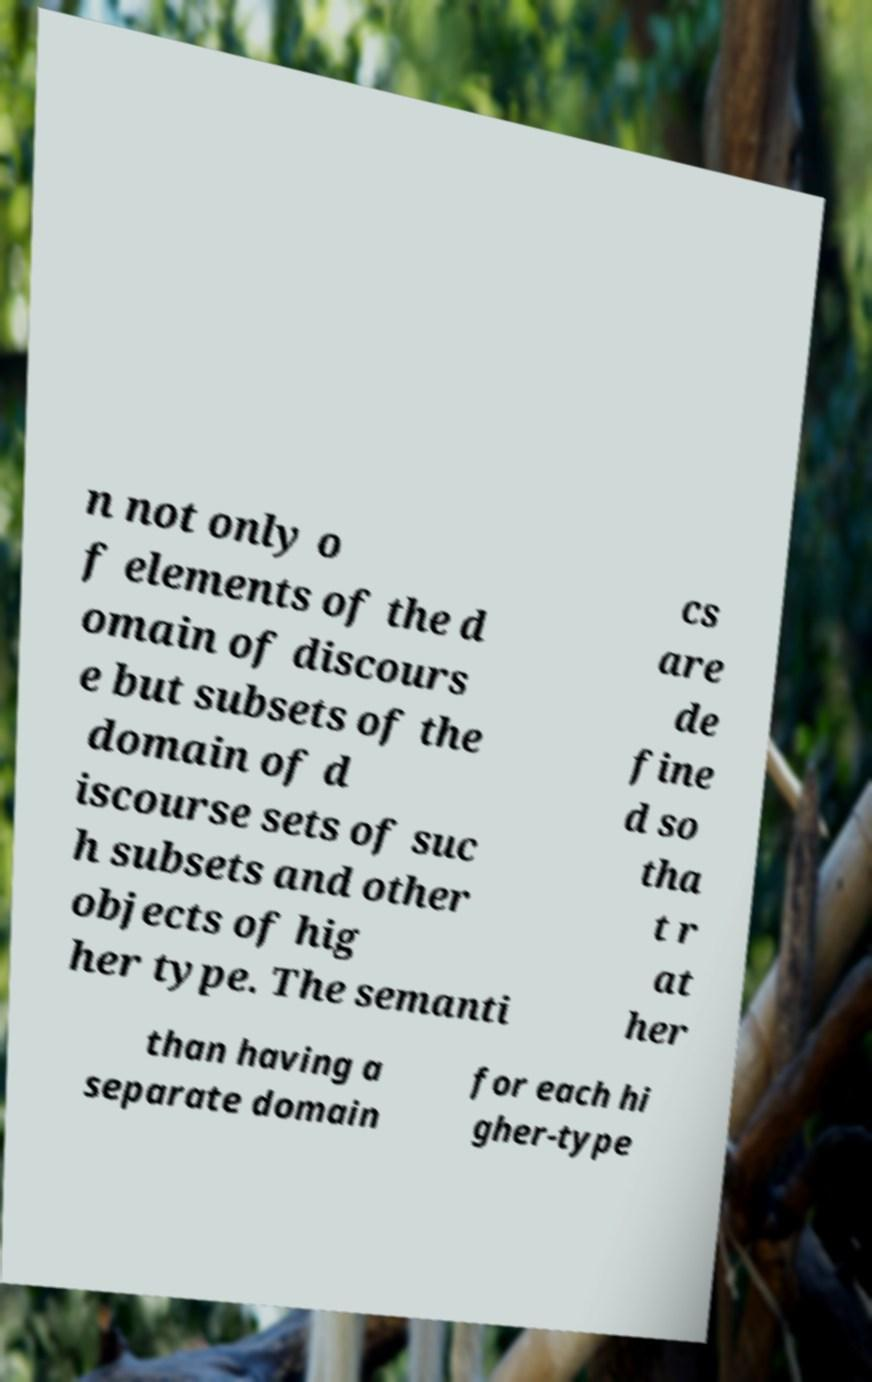Can you accurately transcribe the text from the provided image for me? n not only o f elements of the d omain of discours e but subsets of the domain of d iscourse sets of suc h subsets and other objects of hig her type. The semanti cs are de fine d so tha t r at her than having a separate domain for each hi gher-type 